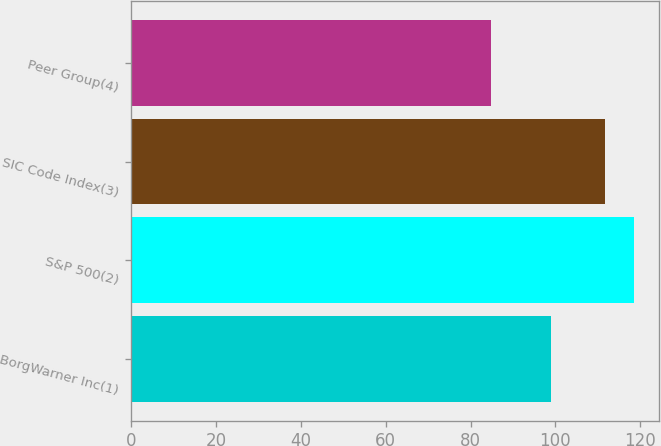<chart> <loc_0><loc_0><loc_500><loc_500><bar_chart><fcel>BorgWarner Inc(1)<fcel>S&P 500(2)<fcel>SIC Code Index(3)<fcel>Peer Group(4)<nl><fcel>98.98<fcel>118.45<fcel>111.67<fcel>84.86<nl></chart> 